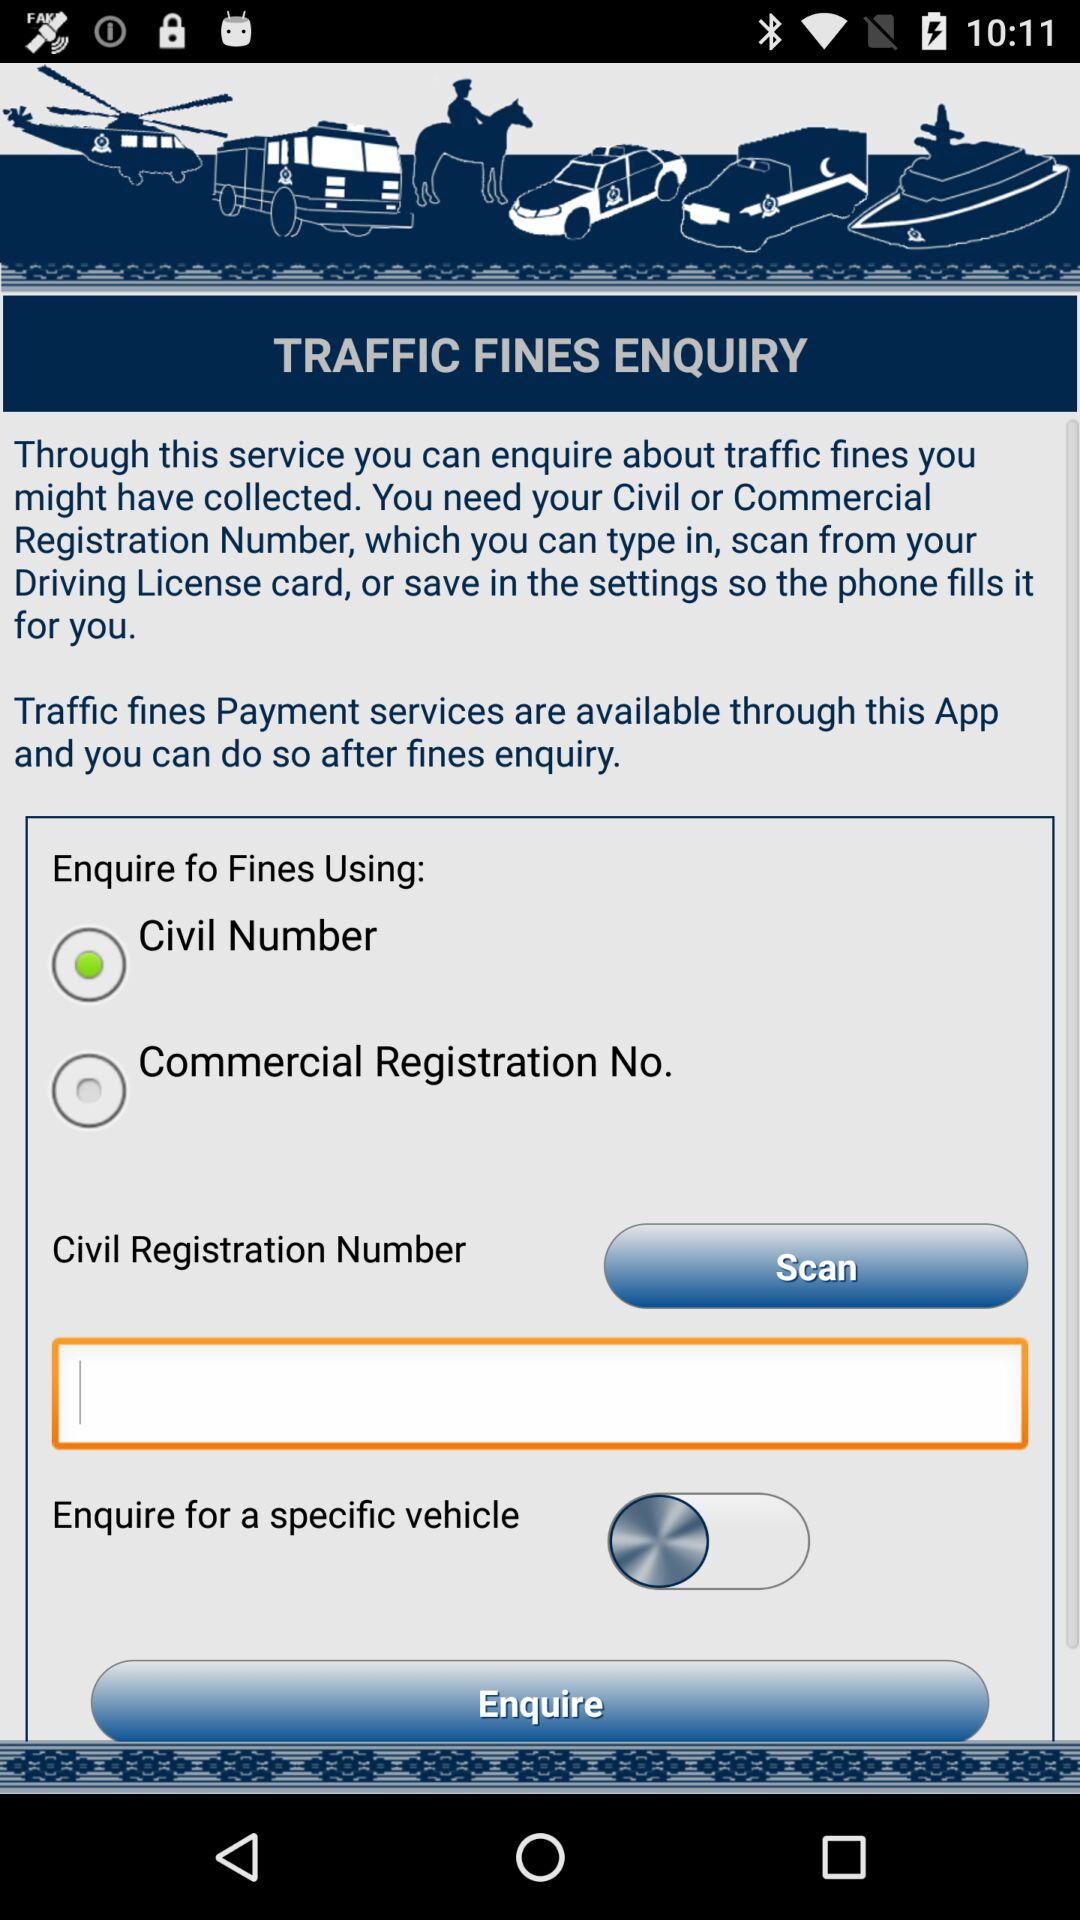What is the civil registration number?
When the provided information is insufficient, respond with <no answer>. <no answer> 